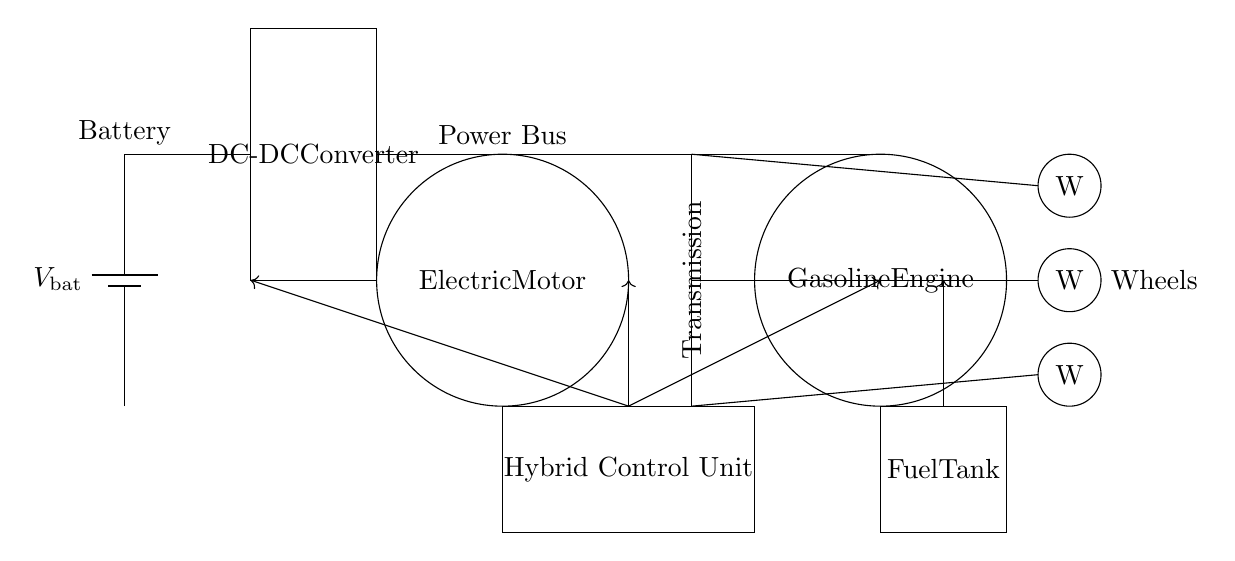What type of motor is shown in the circuit? The circuit diagram indicates an electric motor, as labeled with "Electric Motor." This is crucial because it differentiates it from other types of motors that might be present in different systems.
Answer: Electric motor How many wheels are depicted in the diagram? The circuit shows three wheels as indicated by the elements labeled "W" at differing vertical positions near the end of the diagram. This is important for understanding the number of drive points in the hybrid vehicle.
Answer: Three What does the DC-DC converter do in this circuit? The DC-DC converter is shown connected between the battery and the electric motor, which suggests that it converts the DC voltage from the battery to a level suitable for the electric motor, necessary for efficient operation.
Answer: Voltage conversion Which unit controls the interaction between the battery and the gasoline engine? The hybrid control unit is illustrated in the diagram, with connections marked, making it clear that it manages the power flow between the battery and gasoline engine to optimize performance.
Answer: Hybrid control unit What is the primary power source for this hybrid system? The battery is represented at the circuit's beginning and serves as a primary source, with a direct power connection to the electric motor and the hybrid control unit, showing its role in energy management.
Answer: Battery Why does the circuit have a gasoline engine included? The gasoline engine is present as an alternative power source when additional power or range is required, indicating the hybrid nature of the vehicle to combine two forms of energy for efficiency.
Answer: Alternative energy source What component directly follows the battery in the circuit? The DC-DC converter immediately follows the battery in the diagram, which is essential for transforming the battery's voltage output to match the electric motor's requirements.
Answer: DC-DC converter 